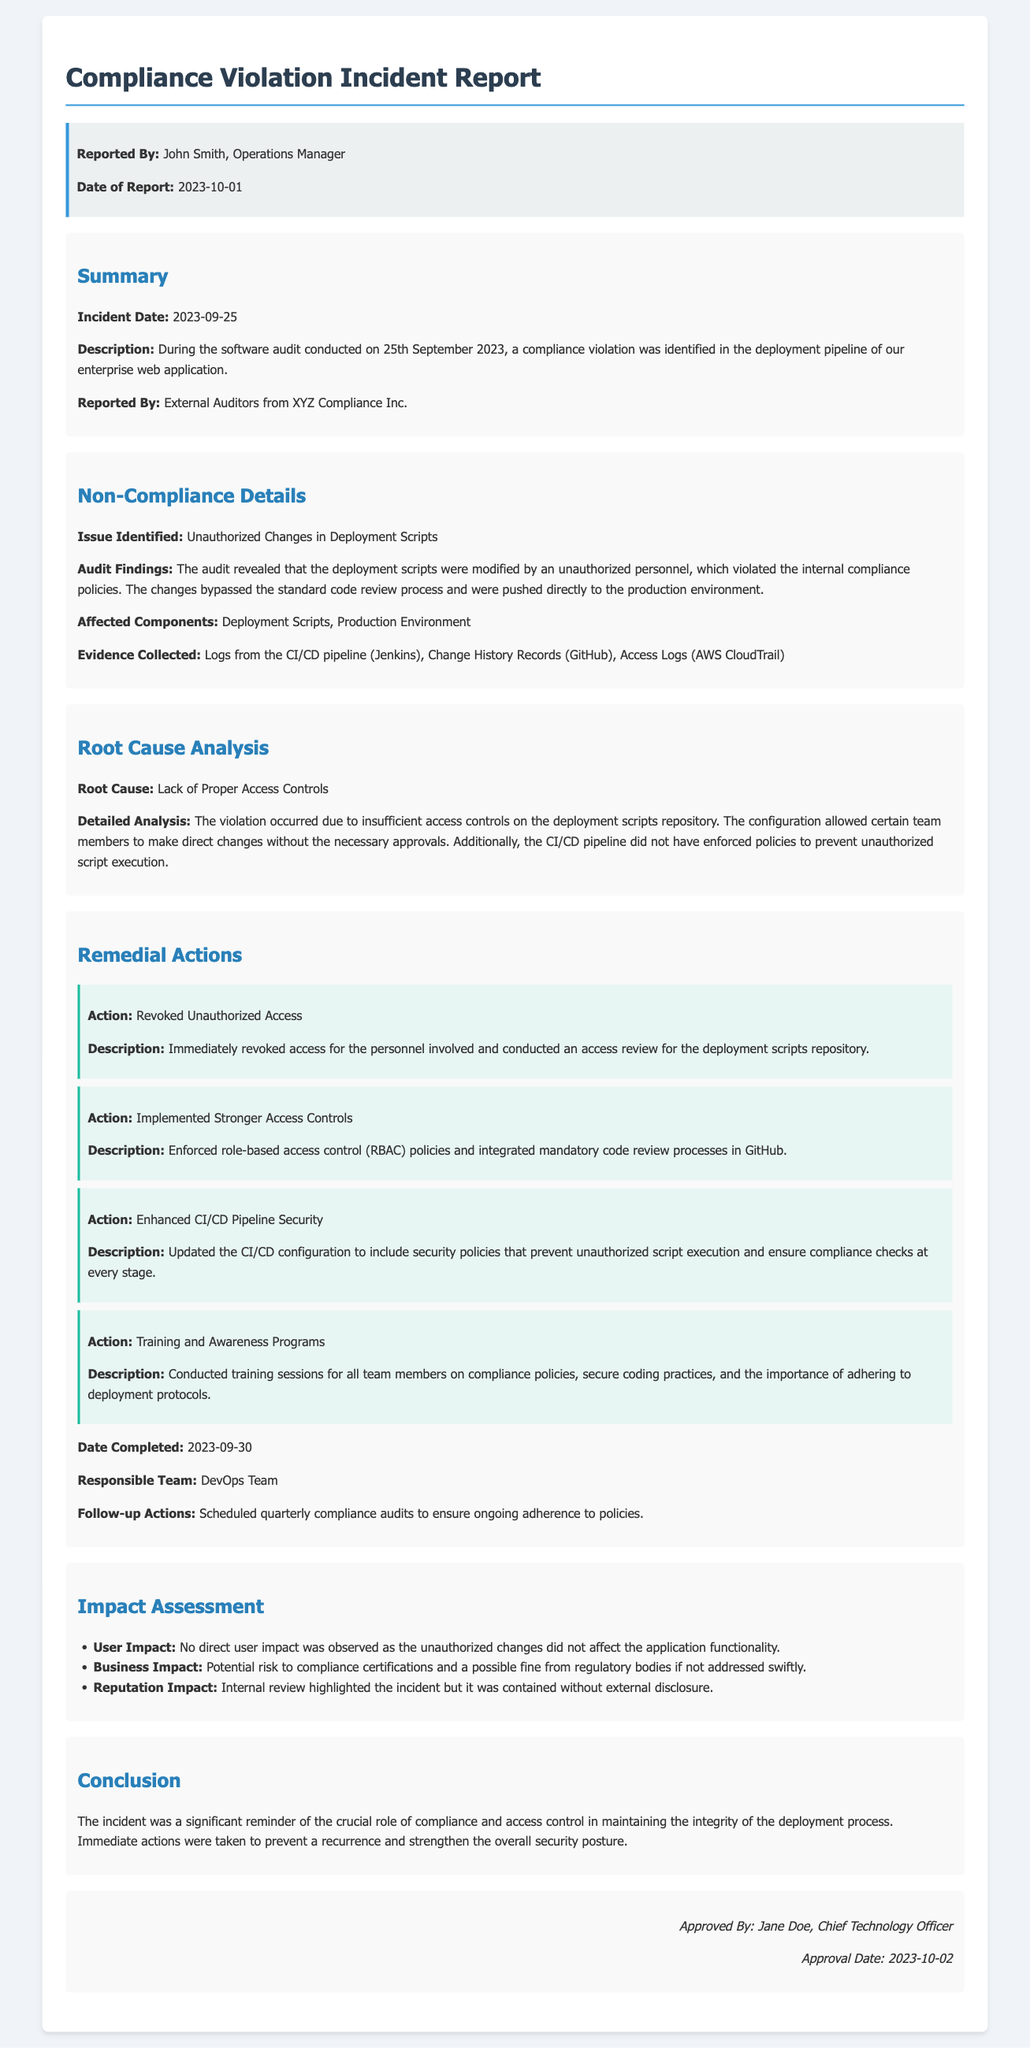What was the incident date? The incident date reported in the document is when the compliance violation occurred, which was 25th September 2023.
Answer: 2023-09-25 Who reported the incident? The report states that John Smith, the Operations Manager, reported the incident.
Answer: John Smith What was the issue identified? The document highlights the specific compliance violation that was detected during the audit, which was unauthorized changes in the deployment scripts.
Answer: Unauthorized Changes in Deployment Scripts What action was taken regarding unauthorized access? The remedial actions section specifies that the organization revoked access for the personnel involved in the incident.
Answer: Revoked Unauthorized Access What is the date when remedial actions were completed? The document mentions that all remedial actions were completed on 30th September 2023.
Answer: 2023-09-30 What was the root cause of the non-compliance? The issue was attributed to a specific reason identified in the report, which was a lack of proper access controls.
Answer: Lack of Proper Access Controls Who approved the incident report? The approval section of the report indicates the person who authorized it, which was Jane Doe, the Chief Technology Officer.
Answer: Jane Doe What was the potential business impact? The document elaborates on the consequences of the incident, highlighting the risk associated with regulatory compliance.
Answer: Potential risk to compliance certifications What is the name of the external auditors? The report states that the audit was conducted by a specific external group that focused on compliance.
Answer: XYZ Compliance Inc What training was conducted after the incident? The remedial actions emphasized the importance of training for team members on specific topics to prevent future issues.
Answer: Training and Awareness Programs 